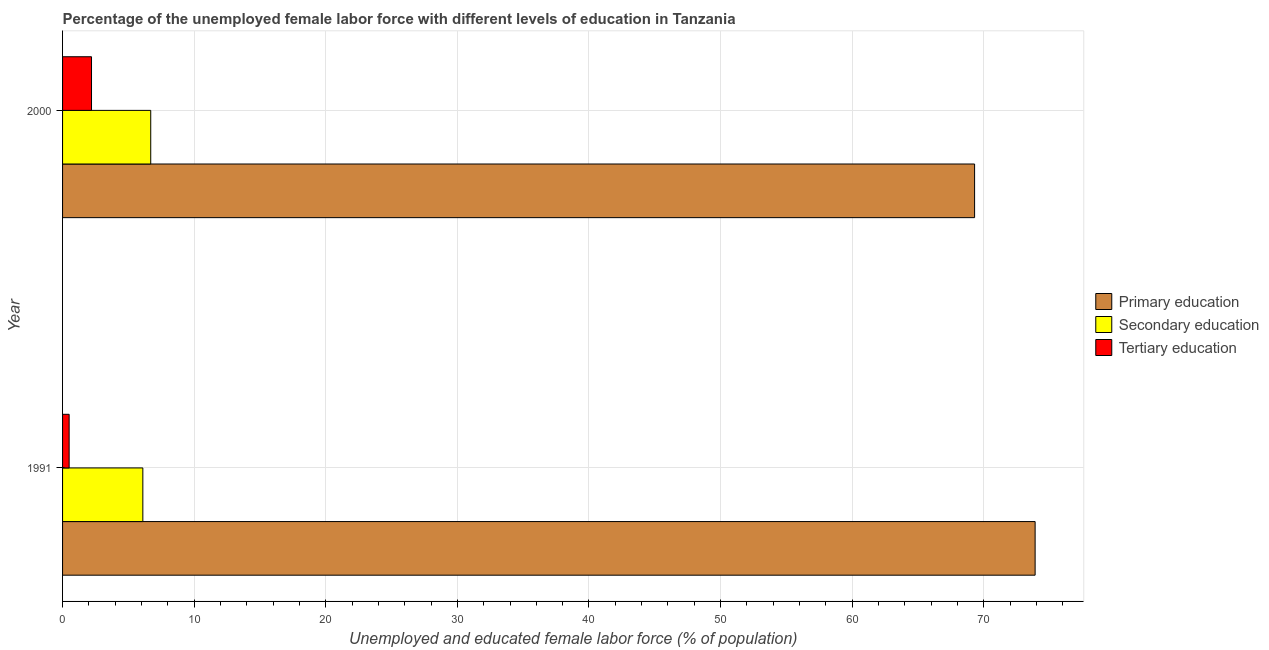How many different coloured bars are there?
Your answer should be very brief. 3. What is the label of the 1st group of bars from the top?
Your answer should be compact. 2000. In how many cases, is the number of bars for a given year not equal to the number of legend labels?
Keep it short and to the point. 0. What is the percentage of female labor force who received primary education in 1991?
Provide a short and direct response. 73.9. Across all years, what is the maximum percentage of female labor force who received tertiary education?
Your response must be concise. 2.2. Across all years, what is the minimum percentage of female labor force who received primary education?
Make the answer very short. 69.3. In which year was the percentage of female labor force who received tertiary education maximum?
Your response must be concise. 2000. In which year was the percentage of female labor force who received secondary education minimum?
Ensure brevity in your answer.  1991. What is the total percentage of female labor force who received tertiary education in the graph?
Offer a very short reply. 2.7. What is the difference between the percentage of female labor force who received primary education in 1991 and that in 2000?
Your answer should be very brief. 4.6. What is the difference between the percentage of female labor force who received primary education in 1991 and the percentage of female labor force who received tertiary education in 2000?
Your answer should be compact. 71.7. What is the average percentage of female labor force who received secondary education per year?
Give a very brief answer. 6.4. In the year 2000, what is the difference between the percentage of female labor force who received secondary education and percentage of female labor force who received tertiary education?
Your response must be concise. 4.5. In how many years, is the percentage of female labor force who received secondary education greater than 60 %?
Your answer should be very brief. 0. What is the ratio of the percentage of female labor force who received primary education in 1991 to that in 2000?
Offer a very short reply. 1.07. Is the percentage of female labor force who received secondary education in 1991 less than that in 2000?
Your answer should be compact. Yes. In how many years, is the percentage of female labor force who received secondary education greater than the average percentage of female labor force who received secondary education taken over all years?
Offer a very short reply. 1. Is it the case that in every year, the sum of the percentage of female labor force who received primary education and percentage of female labor force who received secondary education is greater than the percentage of female labor force who received tertiary education?
Your answer should be compact. Yes. Are all the bars in the graph horizontal?
Offer a terse response. Yes. What is the difference between two consecutive major ticks on the X-axis?
Your response must be concise. 10. Does the graph contain grids?
Your response must be concise. Yes. How many legend labels are there?
Your response must be concise. 3. What is the title of the graph?
Ensure brevity in your answer.  Percentage of the unemployed female labor force with different levels of education in Tanzania. Does "Maunufacturing" appear as one of the legend labels in the graph?
Offer a terse response. No. What is the label or title of the X-axis?
Ensure brevity in your answer.  Unemployed and educated female labor force (% of population). What is the Unemployed and educated female labor force (% of population) in Primary education in 1991?
Provide a short and direct response. 73.9. What is the Unemployed and educated female labor force (% of population) in Secondary education in 1991?
Your response must be concise. 6.1. What is the Unemployed and educated female labor force (% of population) in Tertiary education in 1991?
Provide a succinct answer. 0.5. What is the Unemployed and educated female labor force (% of population) in Primary education in 2000?
Your answer should be compact. 69.3. What is the Unemployed and educated female labor force (% of population) in Secondary education in 2000?
Your answer should be compact. 6.7. What is the Unemployed and educated female labor force (% of population) of Tertiary education in 2000?
Make the answer very short. 2.2. Across all years, what is the maximum Unemployed and educated female labor force (% of population) of Primary education?
Offer a very short reply. 73.9. Across all years, what is the maximum Unemployed and educated female labor force (% of population) of Secondary education?
Ensure brevity in your answer.  6.7. Across all years, what is the maximum Unemployed and educated female labor force (% of population) of Tertiary education?
Your response must be concise. 2.2. Across all years, what is the minimum Unemployed and educated female labor force (% of population) of Primary education?
Your answer should be compact. 69.3. Across all years, what is the minimum Unemployed and educated female labor force (% of population) of Secondary education?
Your response must be concise. 6.1. What is the total Unemployed and educated female labor force (% of population) in Primary education in the graph?
Offer a terse response. 143.2. What is the difference between the Unemployed and educated female labor force (% of population) in Secondary education in 1991 and that in 2000?
Provide a short and direct response. -0.6. What is the difference between the Unemployed and educated female labor force (% of population) in Primary education in 1991 and the Unemployed and educated female labor force (% of population) in Secondary education in 2000?
Your response must be concise. 67.2. What is the difference between the Unemployed and educated female labor force (% of population) in Primary education in 1991 and the Unemployed and educated female labor force (% of population) in Tertiary education in 2000?
Give a very brief answer. 71.7. What is the difference between the Unemployed and educated female labor force (% of population) of Secondary education in 1991 and the Unemployed and educated female labor force (% of population) of Tertiary education in 2000?
Your answer should be very brief. 3.9. What is the average Unemployed and educated female labor force (% of population) in Primary education per year?
Provide a succinct answer. 71.6. What is the average Unemployed and educated female labor force (% of population) of Secondary education per year?
Offer a terse response. 6.4. What is the average Unemployed and educated female labor force (% of population) of Tertiary education per year?
Provide a succinct answer. 1.35. In the year 1991, what is the difference between the Unemployed and educated female labor force (% of population) in Primary education and Unemployed and educated female labor force (% of population) in Secondary education?
Your answer should be compact. 67.8. In the year 1991, what is the difference between the Unemployed and educated female labor force (% of population) in Primary education and Unemployed and educated female labor force (% of population) in Tertiary education?
Offer a very short reply. 73.4. In the year 2000, what is the difference between the Unemployed and educated female labor force (% of population) of Primary education and Unemployed and educated female labor force (% of population) of Secondary education?
Keep it short and to the point. 62.6. In the year 2000, what is the difference between the Unemployed and educated female labor force (% of population) in Primary education and Unemployed and educated female labor force (% of population) in Tertiary education?
Your answer should be compact. 67.1. What is the ratio of the Unemployed and educated female labor force (% of population) in Primary education in 1991 to that in 2000?
Ensure brevity in your answer.  1.07. What is the ratio of the Unemployed and educated female labor force (% of population) in Secondary education in 1991 to that in 2000?
Offer a terse response. 0.91. What is the ratio of the Unemployed and educated female labor force (% of population) in Tertiary education in 1991 to that in 2000?
Keep it short and to the point. 0.23. What is the difference between the highest and the second highest Unemployed and educated female labor force (% of population) of Primary education?
Keep it short and to the point. 4.6. What is the difference between the highest and the lowest Unemployed and educated female labor force (% of population) in Primary education?
Provide a short and direct response. 4.6. What is the difference between the highest and the lowest Unemployed and educated female labor force (% of population) in Secondary education?
Your answer should be compact. 0.6. What is the difference between the highest and the lowest Unemployed and educated female labor force (% of population) in Tertiary education?
Your answer should be compact. 1.7. 